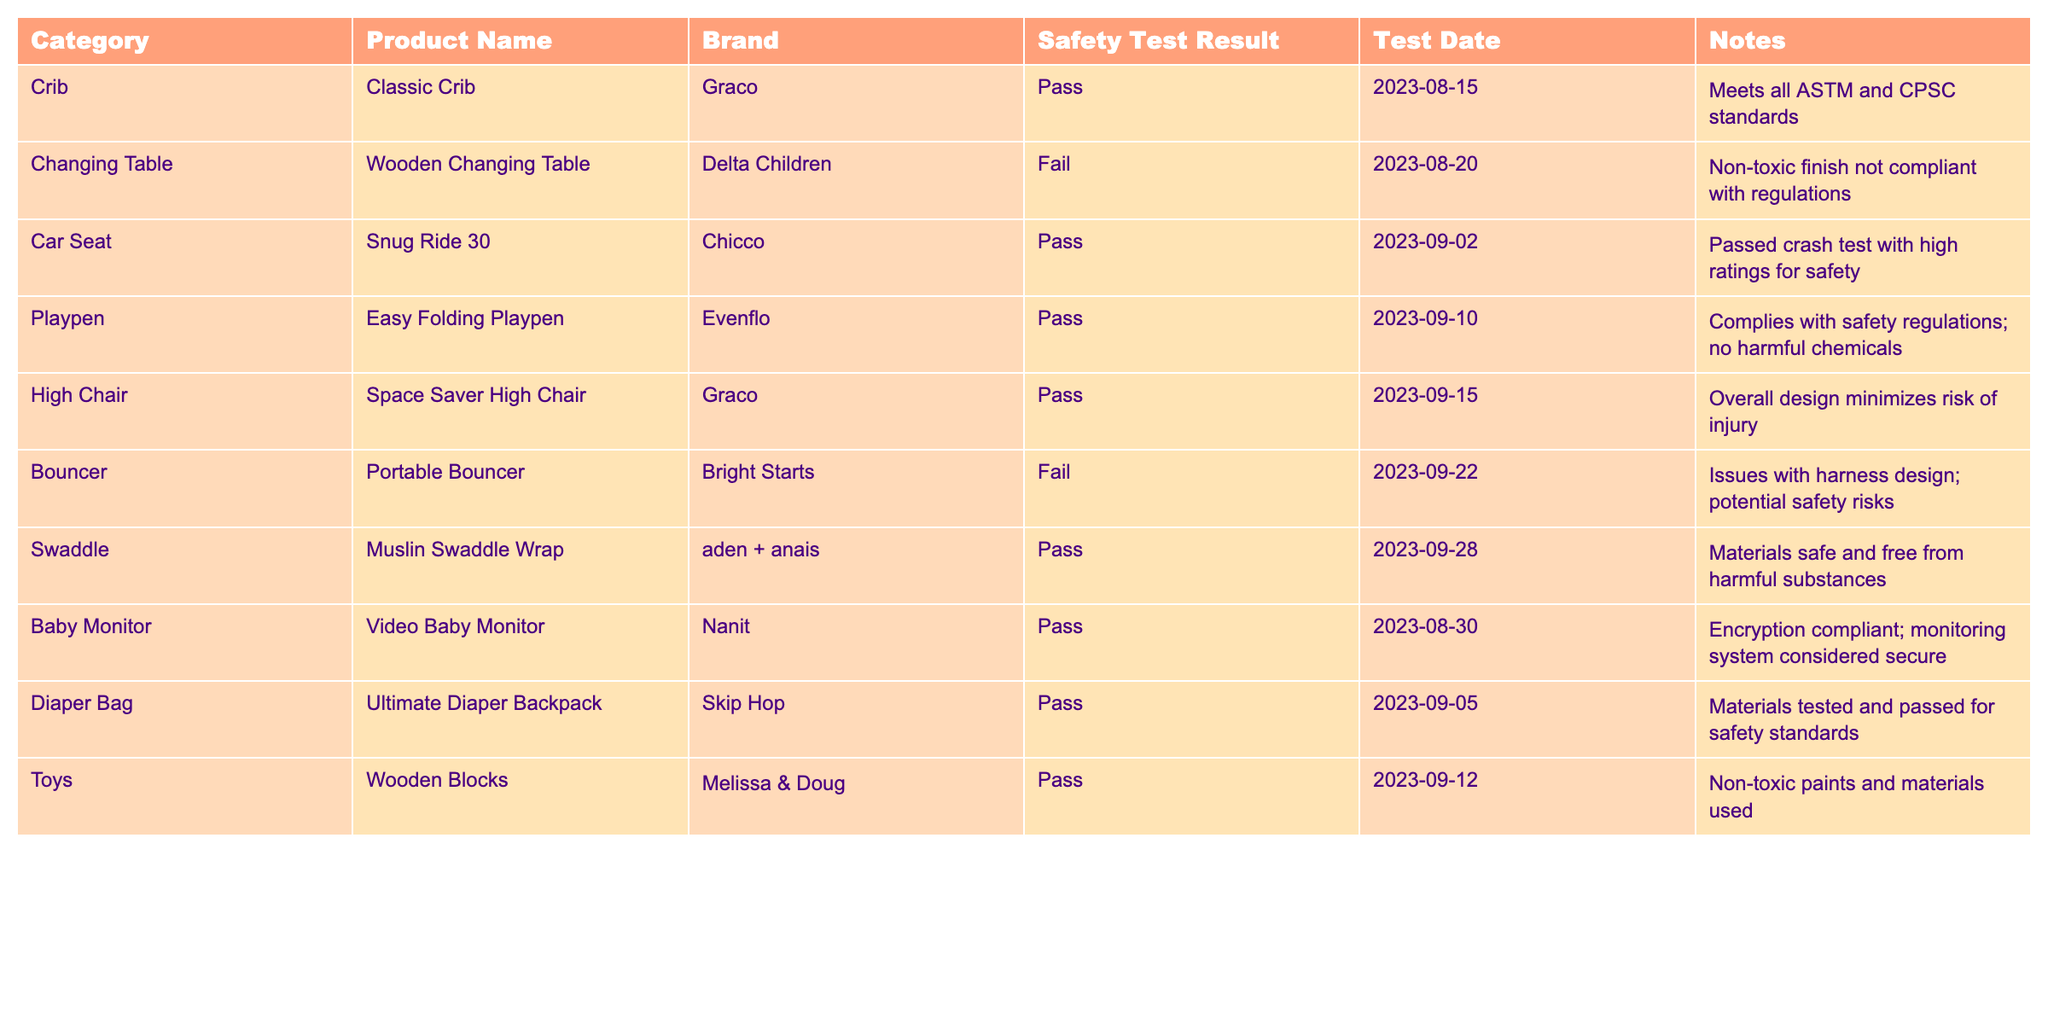What safety test result did the Classic Crib achieve? The table shows that the Classic Crib, produced by Graco, passed the safety test conducted on August 15, 2023.
Answer: Pass How many baby products failed the safety tests? The table lists two products that failed the safety tests: the Wooden Changing Table and the Portable Bouncer.
Answer: 2 Which product had the highest safety test date, and what was the result? The product with the latest safety test date is the Muslin Swaddle Wrap, tested on September 28, 2023, and it passed the safety test.
Answer: Pass Are all toys listed in the table safe based on safety test results? The table shows that the Wooden Blocks by Melissa & Doug passed the safety test, indicating that the toys listed are safe.
Answer: Yes What is the difference between the number of products that passed and failed the safety tests? There are 8 products that passed and 2 that failed. The difference is 8 - 2 = 6.
Answer: 6 Which products comply with safety regulations with no harmful chemicals? Based on the table, the Easy Folding Playpen complies with safety regulations, and the Muslin Swaddle Wrap is also noted for being safe and free from harmful substances.
Answer: Easy Folding Playpen and Muslin Swaddle Wrap What percentage of products passed the safety tests? To calculate the percentage of products that passed, we have 8 passing products out of a total of 10 products. Thus, (8/10) * 100 = 80%.
Answer: 80% What is the safety test result of the Snug Ride 30, and what is noted about its performance? The Snug Ride 30, manufactured by Chicco, passed the safety test and is noted for having passed crash tests with high ratings for safety.
Answer: Pass - high crash test ratings Which brand had two products with failing safety test results? The brands associated with failing products are Delta Children for the Wooden Changing Table and Bright Starts for the Portable Bouncer. Only one brand corresponds to each failing product.
Answer: No brand had two failures 